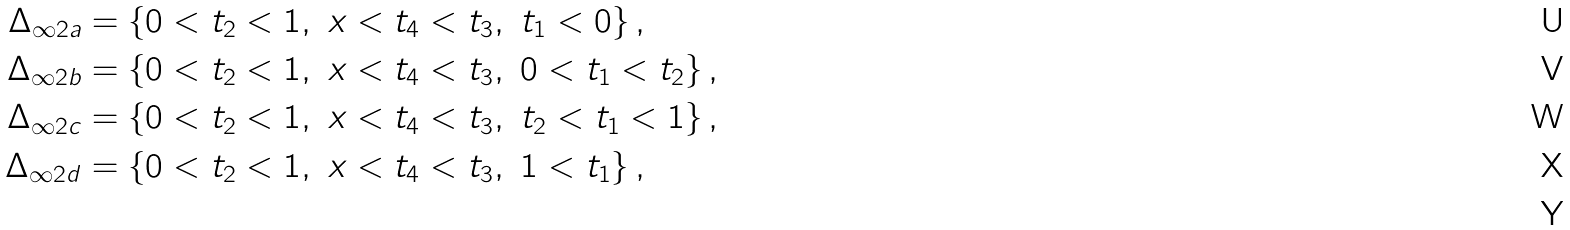Convert formula to latex. <formula><loc_0><loc_0><loc_500><loc_500>\Delta _ { \infty 2 a } & = \{ 0 < t _ { 2 } < 1 , \ x < t _ { 4 } < t _ { 3 } , \ t _ { 1 } < 0 \} \, , \\ \Delta _ { \infty 2 b } & = \{ 0 < t _ { 2 } < 1 , \ x < t _ { 4 } < t _ { 3 } , \ 0 < t _ { 1 } < t _ { 2 } \} \, , \\ \Delta _ { \infty 2 c } & = \{ 0 < t _ { 2 } < 1 , \ x < t _ { 4 } < t _ { 3 } , \ t _ { 2 } < t _ { 1 } < 1 \} \, , \\ \Delta _ { \infty 2 d } & = \{ 0 < t _ { 2 } < 1 , \ x < t _ { 4 } < t _ { 3 } , \ 1 < t _ { 1 } \} \, , \\</formula> 